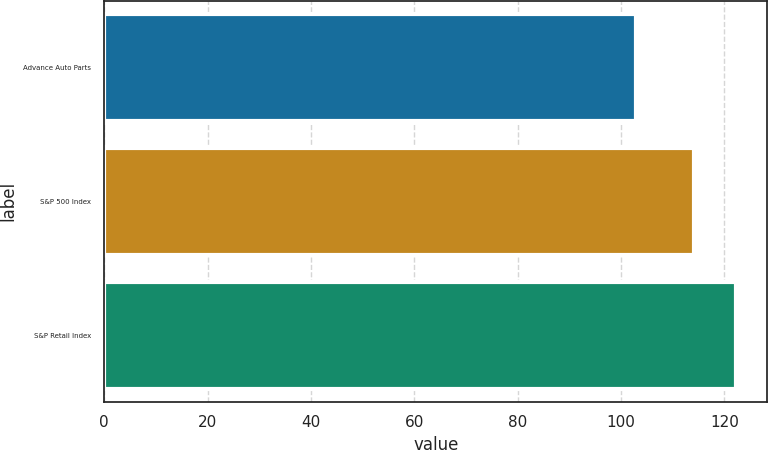Convert chart to OTSL. <chart><loc_0><loc_0><loc_500><loc_500><bar_chart><fcel>Advance Auto Parts<fcel>S&P 500 Index<fcel>S&P Retail Index<nl><fcel>102.87<fcel>114.07<fcel>122.23<nl></chart> 